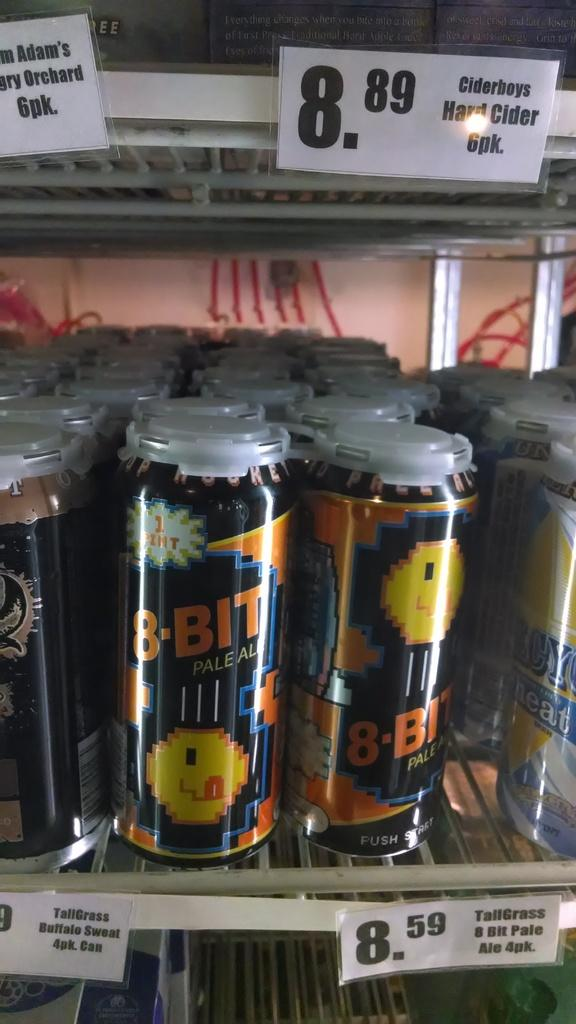<image>
Provide a brief description of the given image. a close up of a fridge with 8-Bit ale for sale 